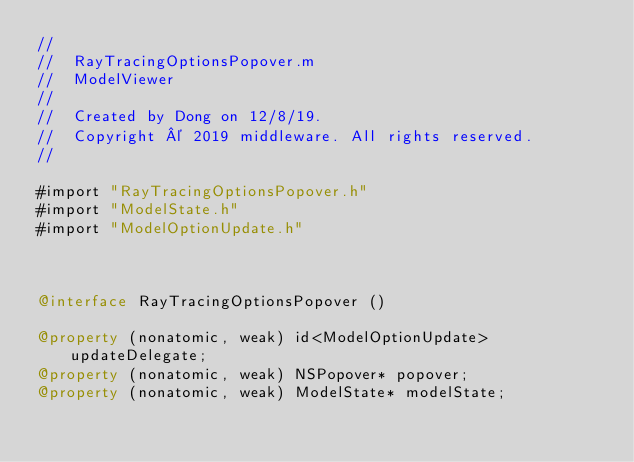<code> <loc_0><loc_0><loc_500><loc_500><_ObjectiveC_>//
//  RayTracingOptionsPopover.m
//  ModelViewer
//
//  Created by Dong on 12/8/19.
//  Copyright © 2019 middleware. All rights reserved.
//

#import "RayTracingOptionsPopover.h"
#import "ModelState.h"
#import "ModelOptionUpdate.h"



@interface RayTracingOptionsPopover ()

@property (nonatomic, weak) id<ModelOptionUpdate> updateDelegate;
@property (nonatomic, weak) NSPopover* popover;
@property (nonatomic, weak) ModelState* modelState;
</code> 